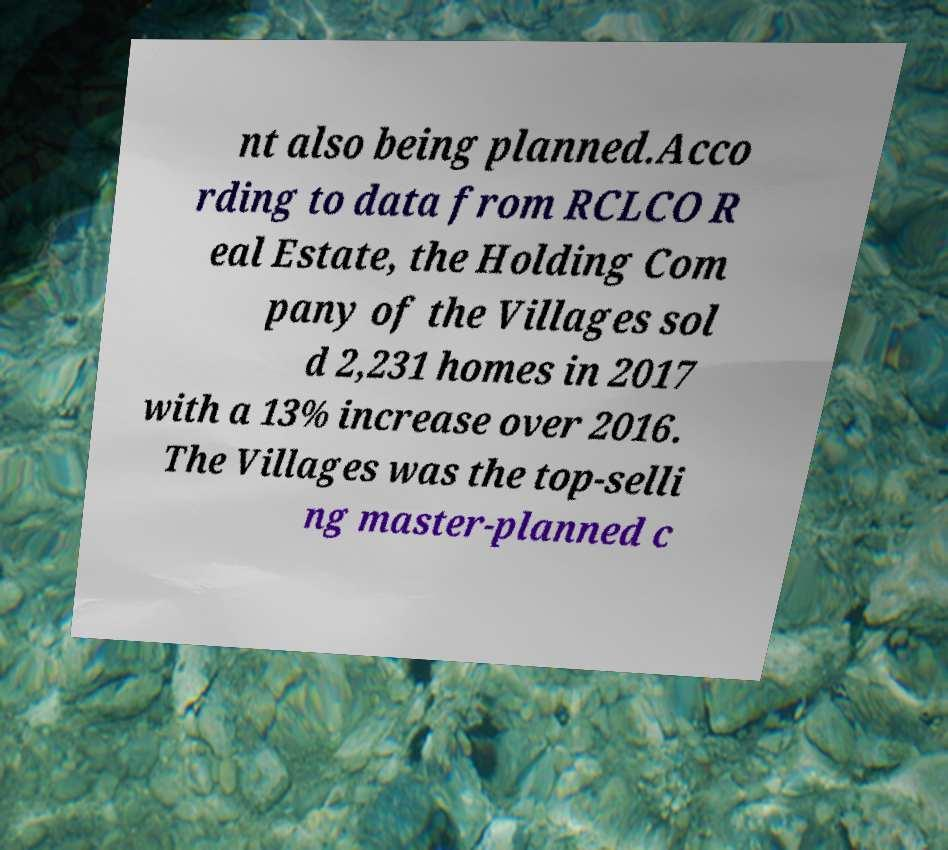What messages or text are displayed in this image? I need them in a readable, typed format. nt also being planned.Acco rding to data from RCLCO R eal Estate, the Holding Com pany of the Villages sol d 2,231 homes in 2017 with a 13% increase over 2016. The Villages was the top-selli ng master-planned c 